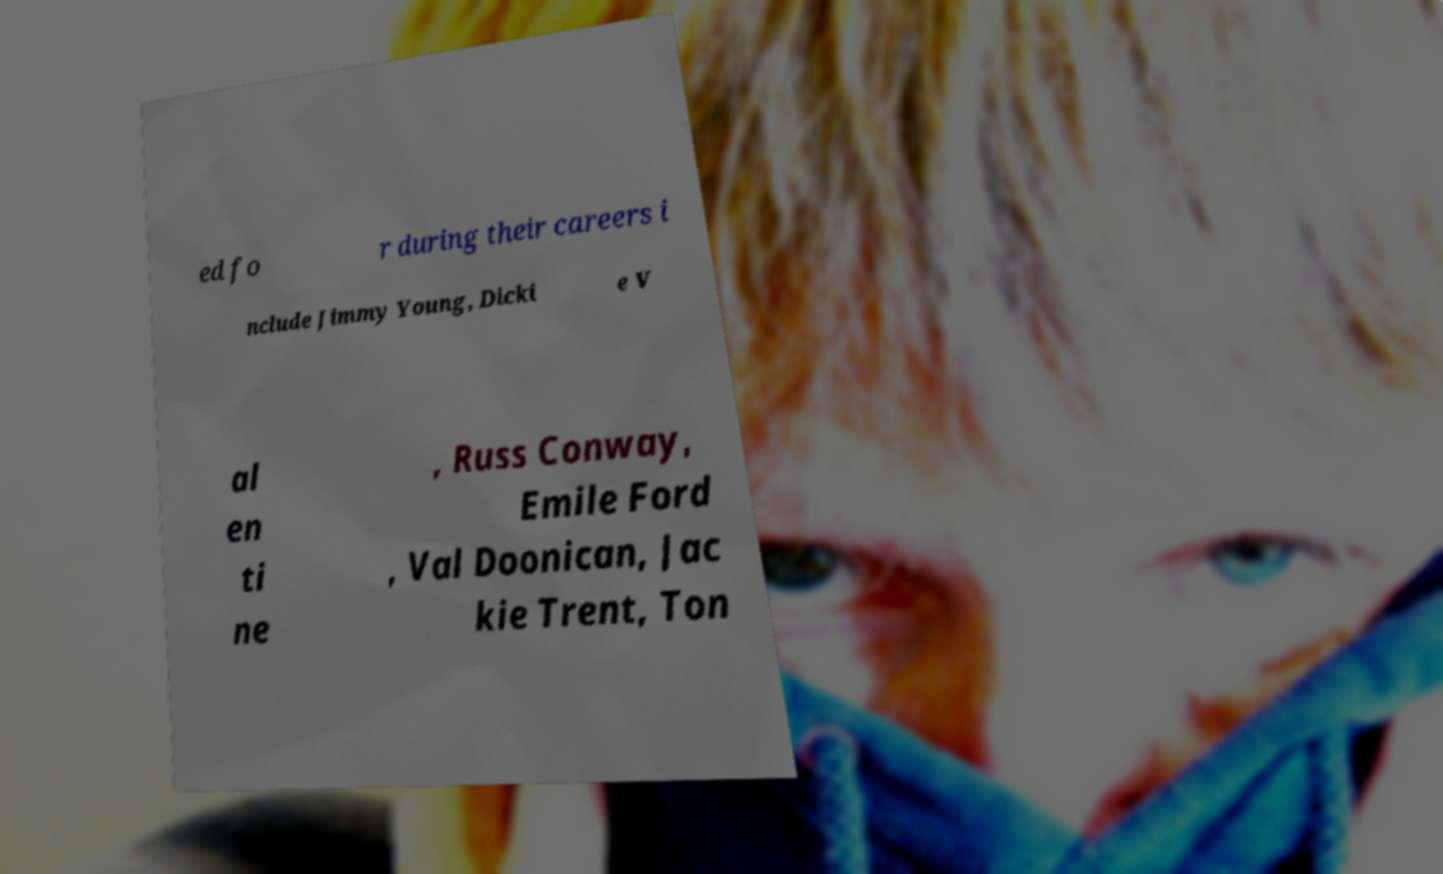For documentation purposes, I need the text within this image transcribed. Could you provide that? ed fo r during their careers i nclude Jimmy Young, Dicki e V al en ti ne , Russ Conway, Emile Ford , Val Doonican, Jac kie Trent, Ton 